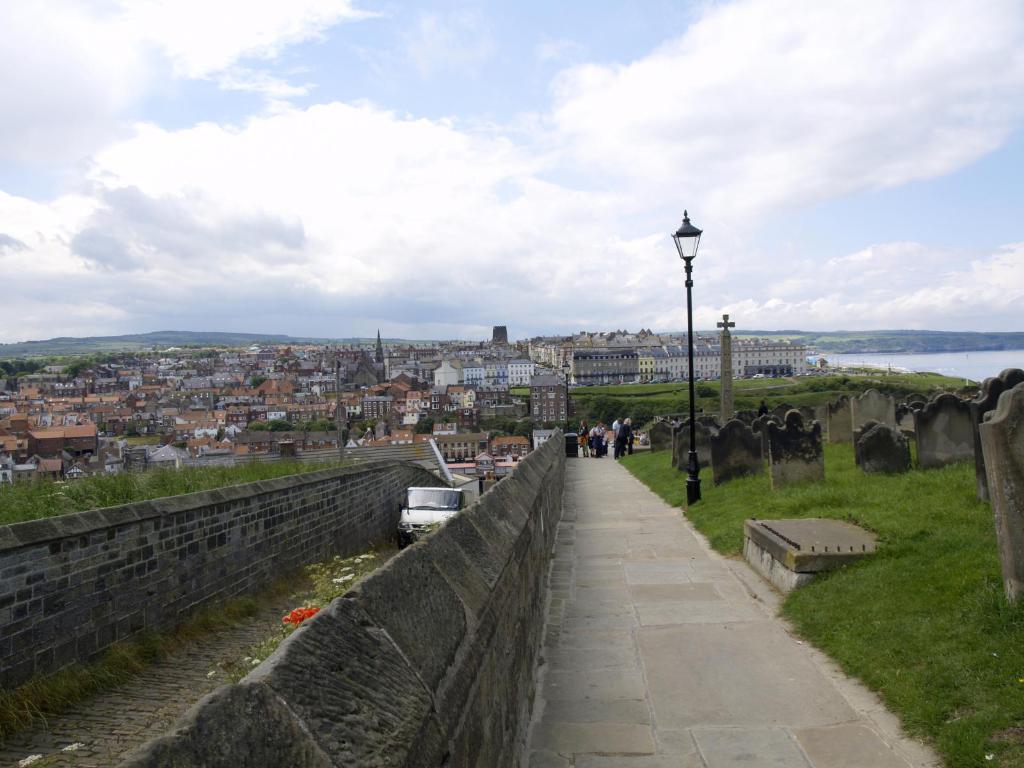How would you summarize this image in a sentence or two? In this picture there is grass land and a pole on the right side of the image and there are buildings in the center of the image, there is sky at the top side of the image. 